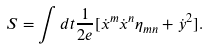Convert formula to latex. <formula><loc_0><loc_0><loc_500><loc_500>S = \int d t \frac { 1 } { 2 e } [ \dot { x } ^ { m } \dot { x } ^ { n } \eta _ { m n } + \dot { y } ^ { 2 } ] .</formula> 